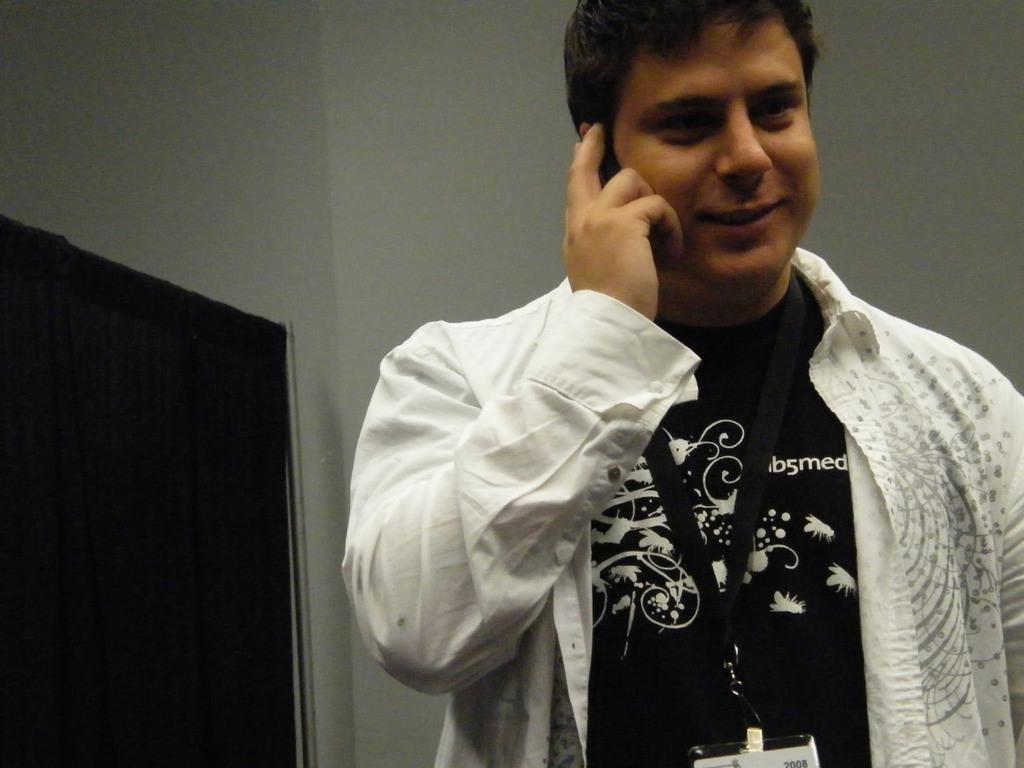Could you give a brief overview of what you see in this image? In this image we can see there is a man in the foreground wearing black and white dress. 